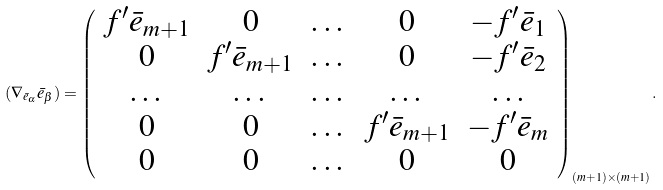Convert formula to latex. <formula><loc_0><loc_0><loc_500><loc_500>( \nabla _ { \bar { e } _ { \alpha } } \bar { e } _ { \beta } ) = \left ( \begin{array} { c c c c c } f ^ { \prime } \bar { e } _ { m + 1 } & 0 & \dots & 0 & - f ^ { \prime } \bar { e } _ { 1 } \\ 0 & f ^ { \prime } \bar { e } _ { m + 1 } & \dots & 0 & - f ^ { \prime } \bar { e } _ { 2 } \\ \dots & \dots & \dots & \dots & \dots \\ 0 & 0 & \dots & f ^ { \prime } \bar { e } _ { m + 1 } & - f ^ { \prime } \bar { e } _ { m } \\ 0 & 0 & \dots & 0 & 0 \\ \end{array} \right ) _ { ( m + 1 ) \times ( m + 1 ) } .</formula> 